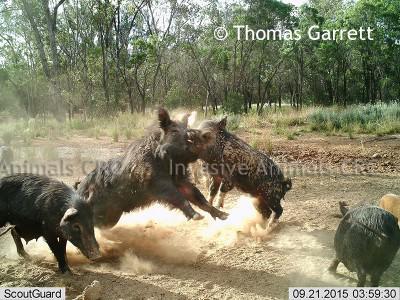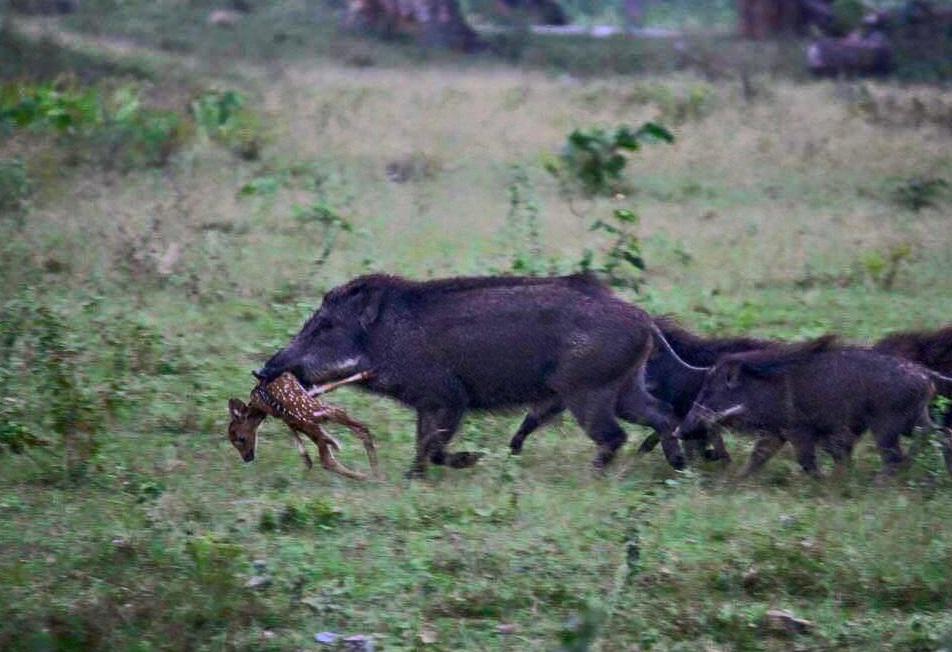The first image is the image on the left, the second image is the image on the right. For the images displayed, is the sentence "There are at least two boars in the left image." factually correct? Answer yes or no. Yes. The first image is the image on the left, the second image is the image on the right. Assess this claim about the two images: "An image shows one boar standing over the dead body of a hooved animal.". Correct or not? Answer yes or no. No. 